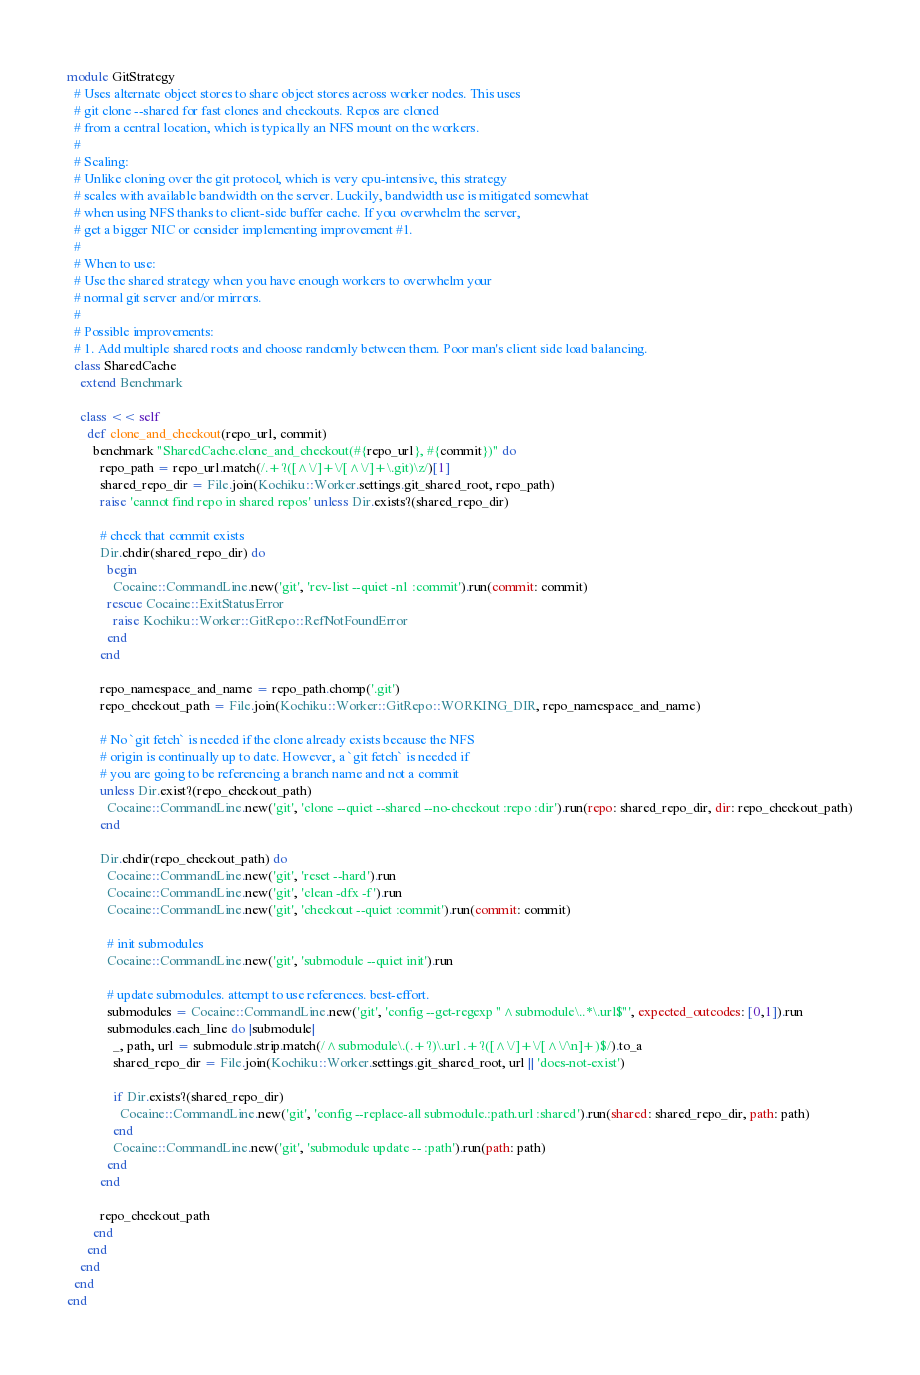<code> <loc_0><loc_0><loc_500><loc_500><_Ruby_>module GitStrategy
  # Uses alternate object stores to share object stores across worker nodes. This uses
  # git clone --shared for fast clones and checkouts. Repos are cloned
  # from a central location, which is typically an NFS mount on the workers.
  #
  # Scaling:
  # Unlike cloning over the git protocol, which is very cpu-intensive, this strategy
  # scales with available bandwidth on the server. Luckily, bandwidth use is mitigated somewhat
  # when using NFS thanks to client-side buffer cache. If you overwhelm the server,
  # get a bigger NIC or consider implementing improvement #1.
  #
  # When to use:
  # Use the shared strategy when you have enough workers to overwhelm your
  # normal git server and/or mirrors.
  #
  # Possible improvements:
  # 1. Add multiple shared roots and choose randomly between them. Poor man's client side load balancing.
  class SharedCache
    extend Benchmark

    class << self
      def clone_and_checkout(repo_url, commit)
        benchmark "SharedCache.clone_and_checkout(#{repo_url}, #{commit})" do
          repo_path = repo_url.match(/.+?([^\/]+\/[^\/]+\.git)\z/)[1]
          shared_repo_dir = File.join(Kochiku::Worker.settings.git_shared_root, repo_path)
          raise 'cannot find repo in shared repos' unless Dir.exists?(shared_repo_dir)

          # check that commit exists
          Dir.chdir(shared_repo_dir) do
            begin
              Cocaine::CommandLine.new('git', 'rev-list --quiet -n1 :commit').run(commit: commit)
            rescue Cocaine::ExitStatusError
              raise Kochiku::Worker::GitRepo::RefNotFoundError
            end
          end

          repo_namespace_and_name = repo_path.chomp('.git')
          repo_checkout_path = File.join(Kochiku::Worker::GitRepo::WORKING_DIR, repo_namespace_and_name)

          # No `git fetch` is needed if the clone already exists because the NFS
          # origin is continually up to date. However, a `git fetch` is needed if
          # you are going to be referencing a branch name and not a commit
          unless Dir.exist?(repo_checkout_path)
            Cocaine::CommandLine.new('git', 'clone --quiet --shared --no-checkout :repo :dir').run(repo: shared_repo_dir, dir: repo_checkout_path)
          end

          Dir.chdir(repo_checkout_path) do
            Cocaine::CommandLine.new('git', 'reset --hard').run
            Cocaine::CommandLine.new('git', 'clean -dfx -f').run
            Cocaine::CommandLine.new('git', 'checkout --quiet :commit').run(commit: commit)

            # init submodules
            Cocaine::CommandLine.new('git', 'submodule --quiet init').run

            # update submodules. attempt to use references. best-effort.
            submodules = Cocaine::CommandLine.new('git', 'config --get-regexp "^submodule\..*\.url$"', expected_outcodes: [0,1]).run
            submodules.each_line do |submodule|
              _, path, url = submodule.strip.match(/^submodule\.(.+?)\.url .+?([^\/]+\/[^\/\n]+)$/).to_a
              shared_repo_dir = File.join(Kochiku::Worker.settings.git_shared_root, url || 'does-not-exist')

              if Dir.exists?(shared_repo_dir)
                Cocaine::CommandLine.new('git', 'config --replace-all submodule.:path.url :shared').run(shared: shared_repo_dir, path: path)
              end
              Cocaine::CommandLine.new('git', 'submodule update -- :path').run(path: path)
            end
          end

          repo_checkout_path
        end
      end
    end
  end
end
</code> 